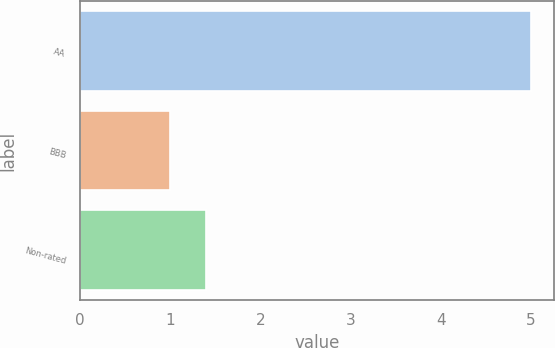Convert chart to OTSL. <chart><loc_0><loc_0><loc_500><loc_500><bar_chart><fcel>AA<fcel>BBB<fcel>Non-rated<nl><fcel>5<fcel>1<fcel>1.4<nl></chart> 